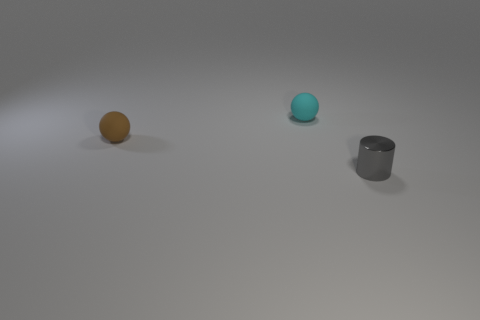Add 1 tiny cyan rubber spheres. How many objects exist? 4 Subtract all balls. How many objects are left? 1 Add 2 big red rubber things. How many big red rubber things exist? 2 Subtract 0 purple balls. How many objects are left? 3 Subtract all tiny matte spheres. Subtract all brown spheres. How many objects are left? 0 Add 3 gray metal things. How many gray metal things are left? 4 